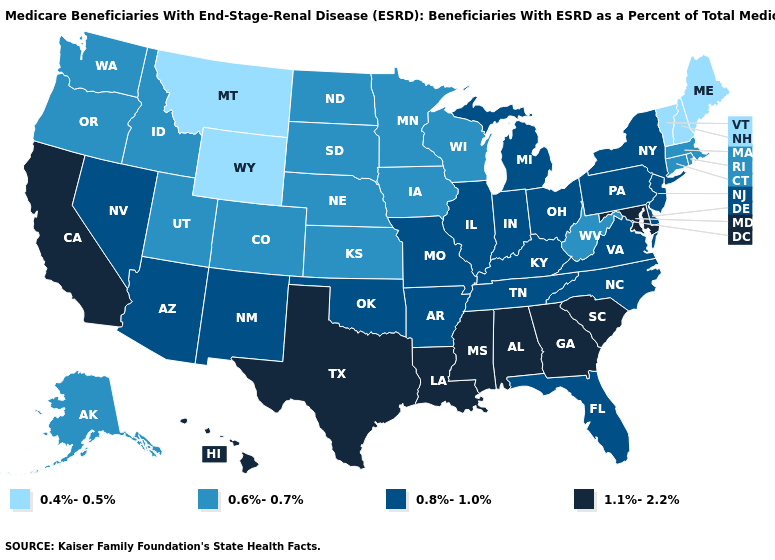Among the states that border New Jersey , which have the highest value?
Write a very short answer. Delaware, New York, Pennsylvania. What is the lowest value in the Northeast?
Be succinct. 0.4%-0.5%. Among the states that border Wyoming , does Montana have the highest value?
Give a very brief answer. No. Among the states that border South Carolina , does Georgia have the lowest value?
Quick response, please. No. Which states hav the highest value in the Northeast?
Keep it brief. New Jersey, New York, Pennsylvania. Name the states that have a value in the range 0.6%-0.7%?
Short answer required. Alaska, Colorado, Connecticut, Idaho, Iowa, Kansas, Massachusetts, Minnesota, Nebraska, North Dakota, Oregon, Rhode Island, South Dakota, Utah, Washington, West Virginia, Wisconsin. What is the lowest value in the Northeast?
Keep it brief. 0.4%-0.5%. Name the states that have a value in the range 0.6%-0.7%?
Concise answer only. Alaska, Colorado, Connecticut, Idaho, Iowa, Kansas, Massachusetts, Minnesota, Nebraska, North Dakota, Oregon, Rhode Island, South Dakota, Utah, Washington, West Virginia, Wisconsin. What is the lowest value in the Northeast?
Short answer required. 0.4%-0.5%. Does the map have missing data?
Keep it brief. No. Among the states that border Connecticut , which have the highest value?
Concise answer only. New York. Does the map have missing data?
Write a very short answer. No. What is the value of Alabama?
Give a very brief answer. 1.1%-2.2%. What is the highest value in the USA?
Give a very brief answer. 1.1%-2.2%. What is the lowest value in states that border Georgia?
Answer briefly. 0.8%-1.0%. 